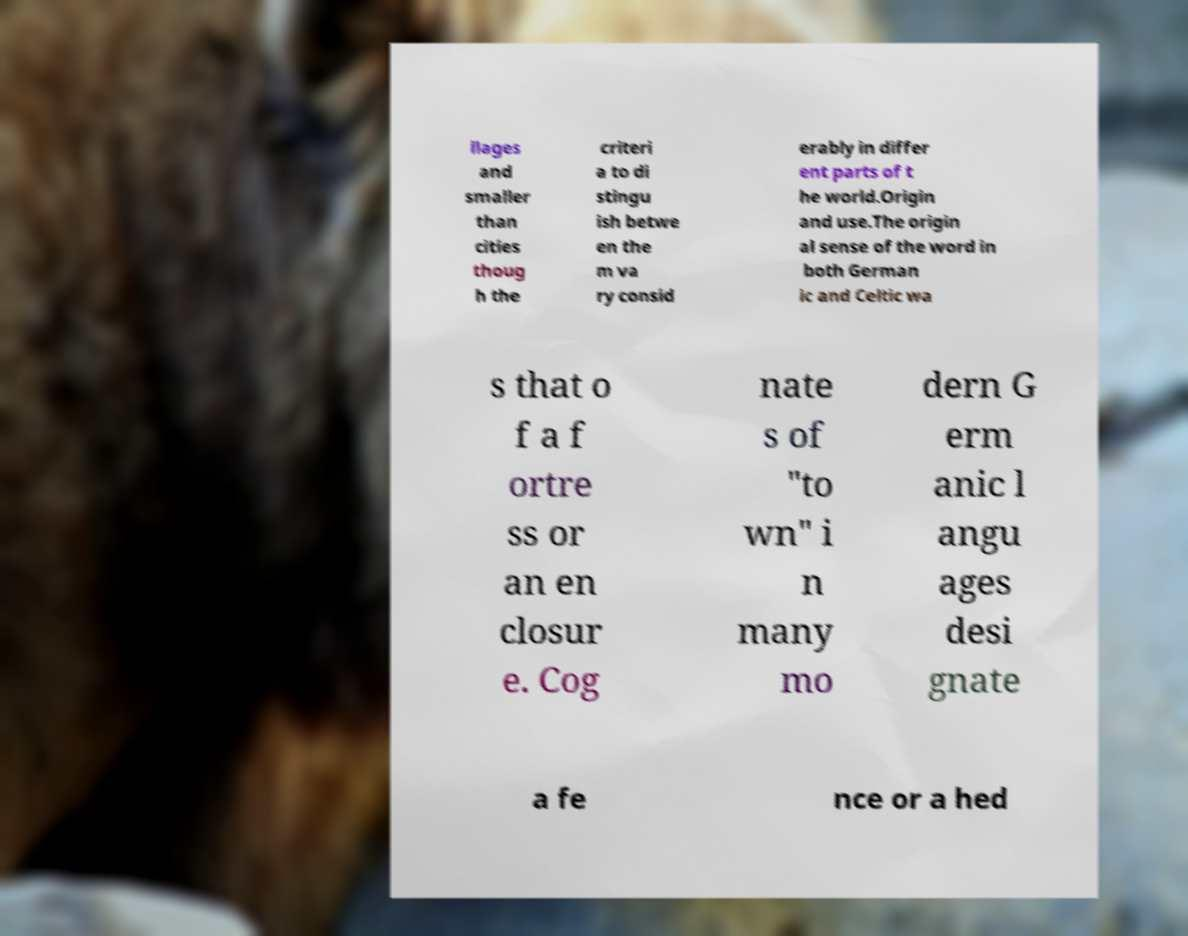What messages or text are displayed in this image? I need them in a readable, typed format. llages and smaller than cities thoug h the criteri a to di stingu ish betwe en the m va ry consid erably in differ ent parts of t he world.Origin and use.The origin al sense of the word in both German ic and Celtic wa s that o f a f ortre ss or an en closur e. Cog nate s of "to wn" i n many mo dern G erm anic l angu ages desi gnate a fe nce or a hed 